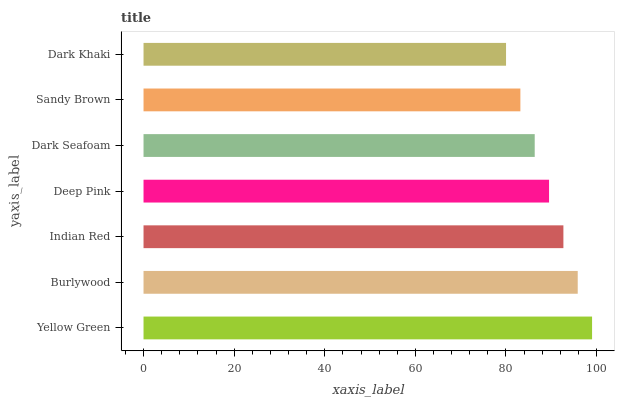Is Dark Khaki the minimum?
Answer yes or no. Yes. Is Yellow Green the maximum?
Answer yes or no. Yes. Is Burlywood the minimum?
Answer yes or no. No. Is Burlywood the maximum?
Answer yes or no. No. Is Yellow Green greater than Burlywood?
Answer yes or no. Yes. Is Burlywood less than Yellow Green?
Answer yes or no. Yes. Is Burlywood greater than Yellow Green?
Answer yes or no. No. Is Yellow Green less than Burlywood?
Answer yes or no. No. Is Deep Pink the high median?
Answer yes or no. Yes. Is Deep Pink the low median?
Answer yes or no. Yes. Is Burlywood the high median?
Answer yes or no. No. Is Yellow Green the low median?
Answer yes or no. No. 